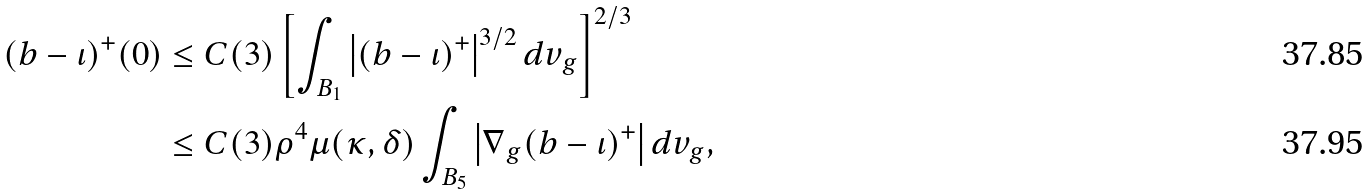Convert formula to latex. <formula><loc_0><loc_0><loc_500><loc_500>( b - \iota ) ^ { + } ( 0 ) & \leq C ( 3 ) \left [ \int _ { B _ { 1 } } \left | ( b - \iota ) ^ { + } \right | ^ { 3 / 2 } d v _ { g } \right ] ^ { 2 / 3 } \\ & \leq C ( 3 ) \rho ^ { 4 } \mu ( \kappa , \delta ) \int _ { B _ { 5 } } \left | \nabla _ { g } ( b - \iota ) ^ { + } \right | d v _ { g } ,</formula> 